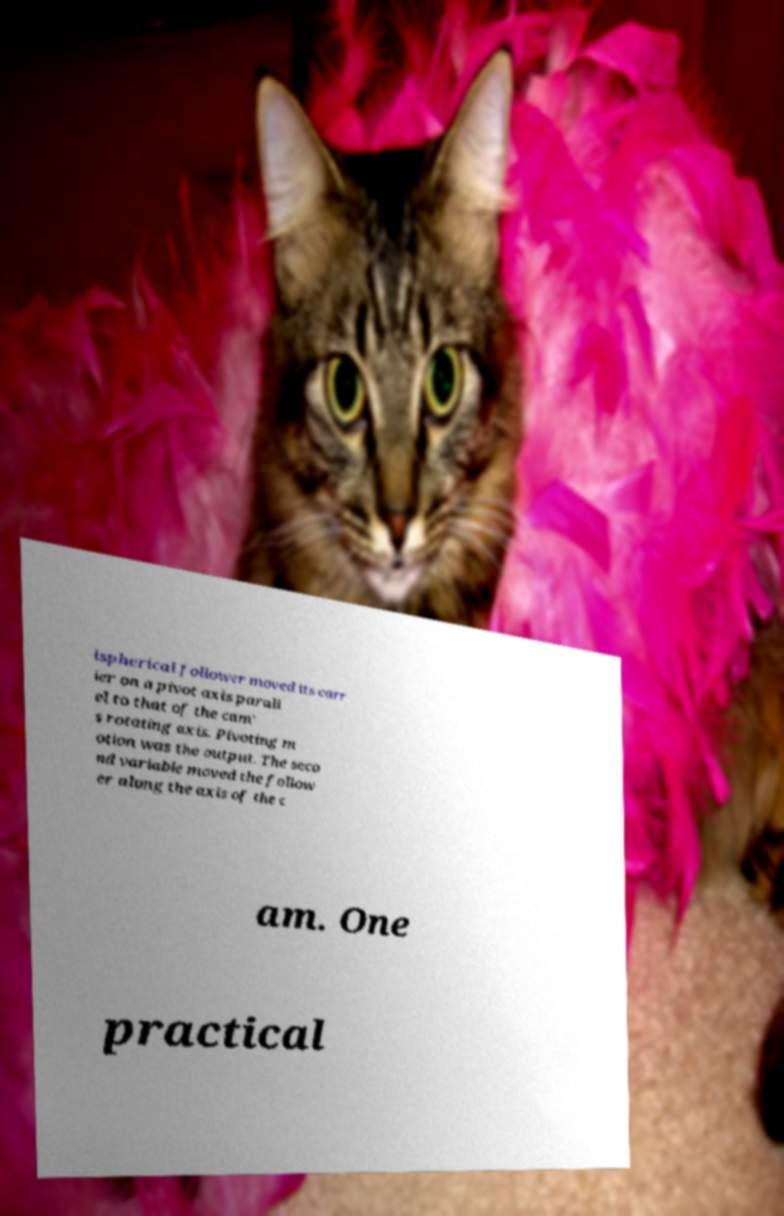For documentation purposes, I need the text within this image transcribed. Could you provide that? ispherical follower moved its carr ier on a pivot axis parall el to that of the cam' s rotating axis. Pivoting m otion was the output. The seco nd variable moved the follow er along the axis of the c am. One practical 